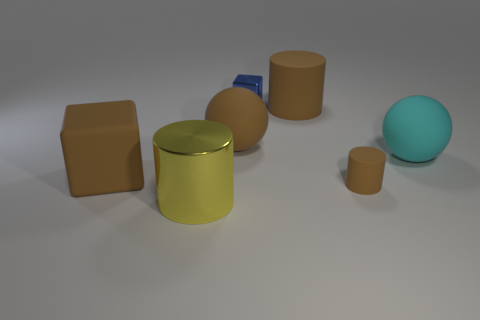Are there any things that are behind the tiny thing in front of the large object that is on the right side of the small brown matte thing? Yes, there appears to be a small blue, rectangular object positioned behind the tiny cylindrical object, which is located in front of a larger cylinder on the right side of the small, brown cube-shaped object. 